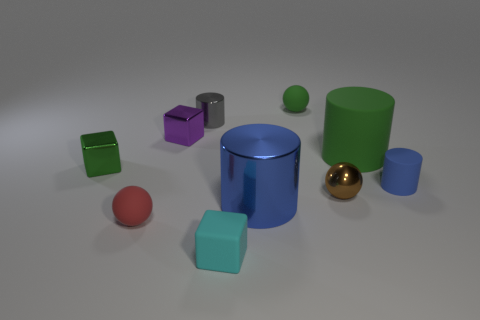Subtract all metallic cubes. How many cubes are left? 1 Subtract 1 cubes. How many cubes are left? 2 Subtract all green cylinders. How many cylinders are left? 3 Subtract all red cylinders. Subtract all brown balls. How many cylinders are left? 4 Subtract all cylinders. How many objects are left? 6 Subtract 1 cyan cubes. How many objects are left? 9 Subtract all blue rubber objects. Subtract all tiny cyan rubber objects. How many objects are left? 8 Add 9 green cylinders. How many green cylinders are left? 10 Add 5 tiny yellow metal cylinders. How many tiny yellow metal cylinders exist? 5 